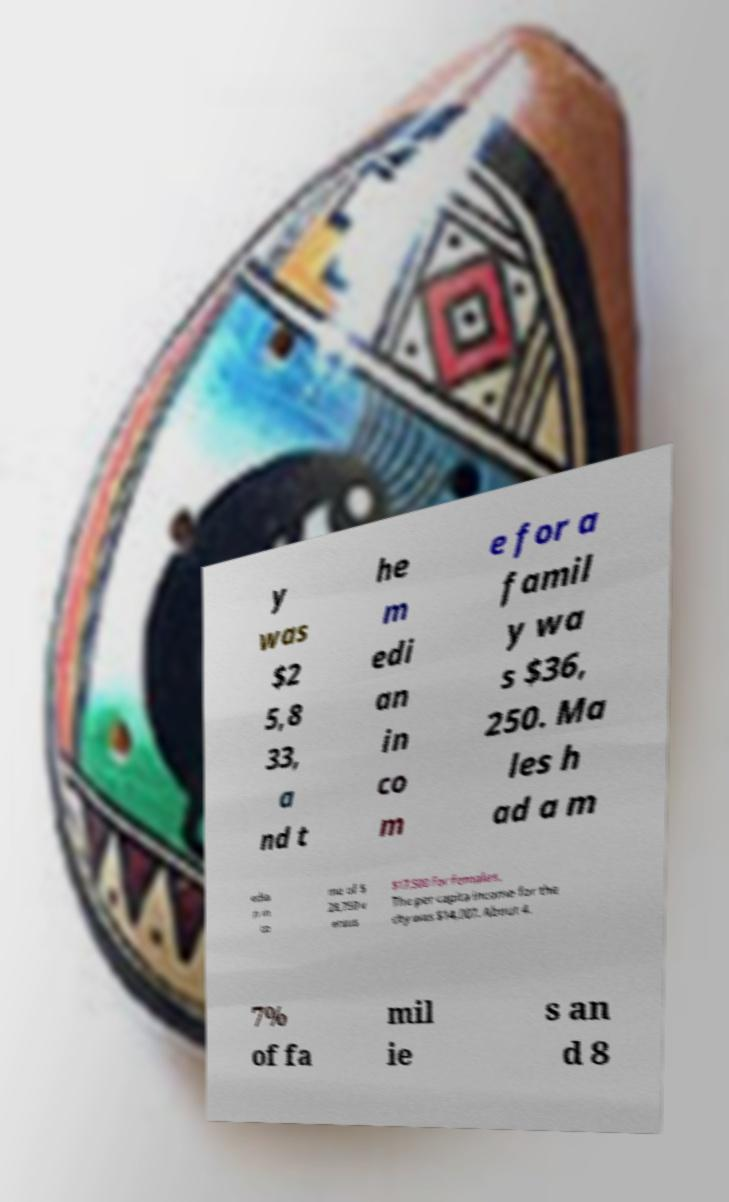Please identify and transcribe the text found in this image. y was $2 5,8 33, a nd t he m edi an in co m e for a famil y wa s $36, 250. Ma les h ad a m edia n in co me of $ 28,750 v ersus $17,500 for females. The per capita income for the city was $14,007. About 4. 7% of fa mil ie s an d 8 